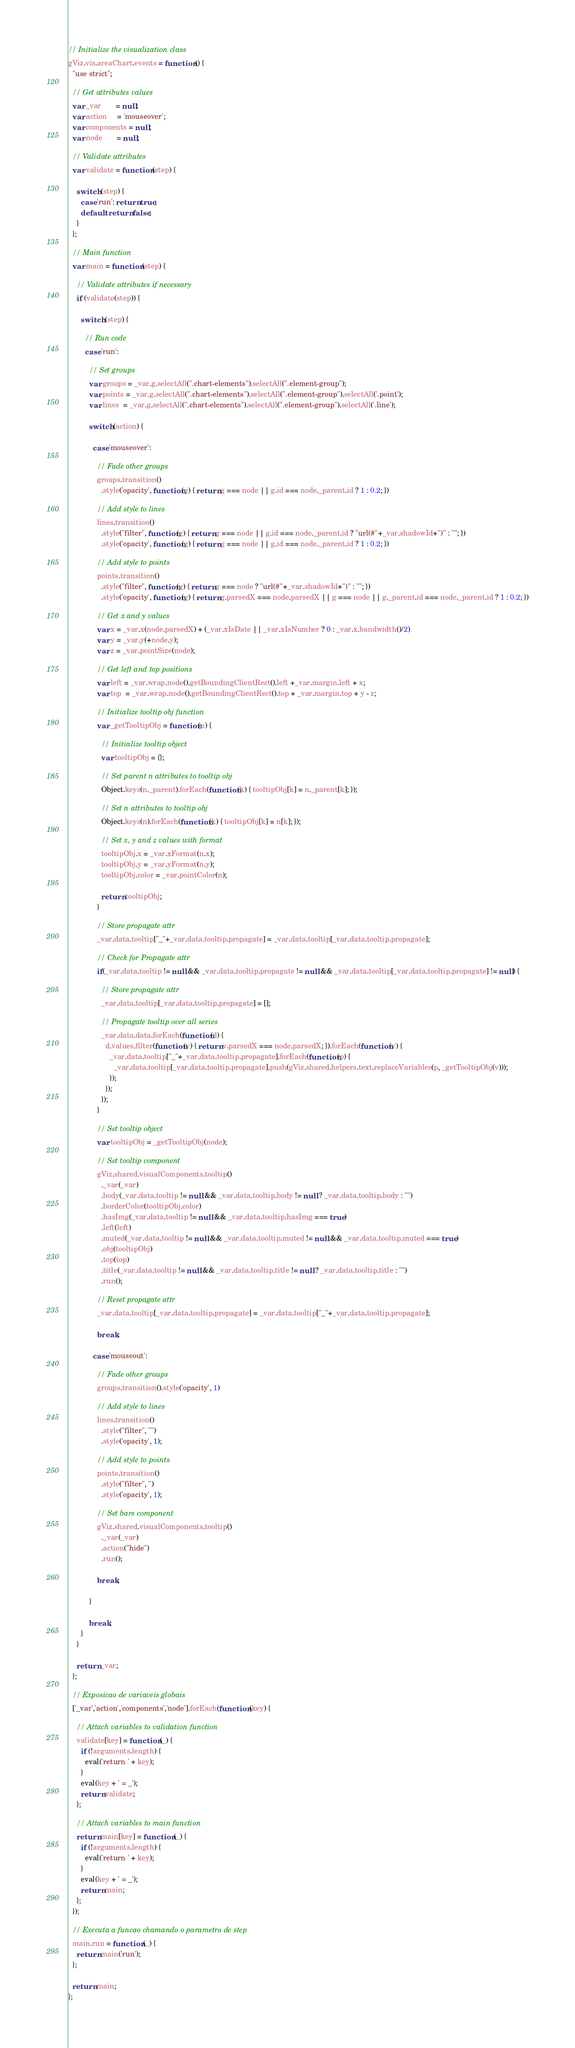Convert code to text. <code><loc_0><loc_0><loc_500><loc_500><_JavaScript_>// Initialize the visualization class
gViz.vis.areaChart.events = function () {
  "use strict";

  // Get attributes values
  var _var       = null;
  var action     = 'mouseover';
  var components = null;
  var node       = null;

  // Validate attributes
  var validate = function (step) {

    switch (step) {
      case 'run': return true;
      default: return false;
    }
  };

  // Main function
  var main = function (step) {

    // Validate attributes if necessary
    if (validate(step)) {

      switch (step) {

        // Run code
        case 'run':

          // Set groups
          var groups = _var.g.selectAll(".chart-elements").selectAll(".element-group");
          var points = _var.g.selectAll(".chart-elements").selectAll(".element-group").selectAll('.point');
          var lines  = _var.g.selectAll(".chart-elements").selectAll(".element-group").selectAll('.line');

          switch (action) {

            case 'mouseover':

              // Fade other groups
              groups.transition()
                .style('opacity', function(g) { return g === node || g.id === node._parent.id ? 1 : 0.2; })

              // Add style to lines
              lines.transition()
                .style("filter", function(g) { return g === node || g.id === node._parent.id ? "url(#"+_var.shadowId+")" : ""; })
                .style('opacity', function(g) { return g === node || g.id === node._parent.id ? 1 : 0.2; })

              // Add style to points
              points.transition()
                .style("filter", function(g) { return g === node ? "url(#"+_var.shadowId+")" : ""; })
                .style('opacity', function(g) { return g.parsedX === node.parsedX || g === node || g._parent.id === node._parent.id ? 1 : 0.2; })

              // Get x and y values
              var x = _var.x(node.parsedX) + (_var.xIsDate || _var.xIsNumber ? 0 : _var.x.bandwidth()/2)
              var y = _var.y(+node.y);
              var z = _var.pointSize(node);

              // Get left and top positions
              var left = _var.wrap.node().getBoundingClientRect().left +_var.margin.left + x;
              var top  = _var.wrap.node().getBoundingClientRect().top + _var.margin.top + y - z;

              // Initialize tooltip obj function
              var _getTooltipObj = function(n) {

                // Initialize tooltip object
                var tooltipObj = {};

                // Set parent n attributes to tooltip obj
                Object.keys(n._parent).forEach(function(k) { tooltipObj[k] = n._parent[k]; });

                // Set n attributes to tooltip obj
                Object.keys(n).forEach(function(k) { tooltipObj[k] = n[k]; });

                // Set x, y and z values with format
                tooltipObj.x = _var.xFormat(n.x);
                tooltipObj.y = _var.yFormat(n.y);
                tooltipObj.color = _var.pointColor(n);

                return tooltipObj;
              }

              // Store propagate attr
              _var.data.tooltip["_"+_var.data.tooltip.propagate] = _var.data.tooltip[_var.data.tooltip.propagate];

              // Check for Propagate attr
              if(_var.data.tooltip != null && _var.data.tooltip.propagate != null && _var.data.tooltip[_var.data.tooltip.propagate] != null) {

                // Store propagate attr
                _var.data.tooltip[_var.data.tooltip.propagate] = [];

                // Propagate tooltip over all series
                _var.data.data.forEach(function(d) {
                  d.values.filter(function(v) { return v.parsedX === node.parsedX; }).forEach(function(v) {
                    _var.data.tooltip["_"+_var.data.tooltip.propagate].forEach(function(p) {
                      _var.data.tooltip[_var.data.tooltip.propagate].push(gViz.shared.helpers.text.replaceVariables(p, _getTooltipObj(v)));
                    });
                  });
                });
              }

              // Set tooltip object
              var tooltipObj = _getTooltipObj(node);

              // Set tooltip component
              gViz.shared.visualComponents.tooltip()
                ._var(_var)
                .body(_var.data.tooltip != null && _var.data.tooltip.body != null ? _var.data.tooltip.body : "")
                .borderColor(tooltipObj.color)
                .hasImg(_var.data.tooltip != null && _var.data.tooltip.hasImg === true)
                .left(left)
                .muted(_var.data.tooltip != null && _var.data.tooltip.muted != null && _var.data.tooltip.muted === true)
                .obj(tooltipObj)
                .top(top)
                .title(_var.data.tooltip != null && _var.data.tooltip.title != null ? _var.data.tooltip.title : "")
                .run();

              // Reset propagate attr
              _var.data.tooltip[_var.data.tooltip.propagate] = _var.data.tooltip["_"+_var.data.tooltip.propagate];

              break;

            case 'mouseout':

              // Fade other groups
              groups.transition().style('opacity', 1)

              // Add style to lines
              lines.transition()
                .style("filter", "")
                .style('opacity', 1);

              // Add style to points
              points.transition()
                .style("filter", '')
                .style('opacity', 1);

              // Set bars component
              gViz.shared.visualComponents.tooltip()
                ._var(_var)
                .action("hide")
                .run();

              break;

          }

          break;
      }
    }

    return _var;
  };

  // Exposicao de variaveis globais
  ['_var','action','components','node'].forEach(function (key) {

    // Attach variables to validation function
    validate[key] = function (_) {
      if (!arguments.length) {
        eval('return ' + key);
      }
      eval(key + ' = _');
      return validate;
    };

    // Attach variables to main function
    return main[key] = function (_) {
      if (!arguments.length) {
        eval('return ' + key);
      }
      eval(key + ' = _');
      return main;
    };
  });

  // Executa a funcao chamando o parametro de step
  main.run = function (_) {
    return main('run');
  };

  return main;
};
</code> 